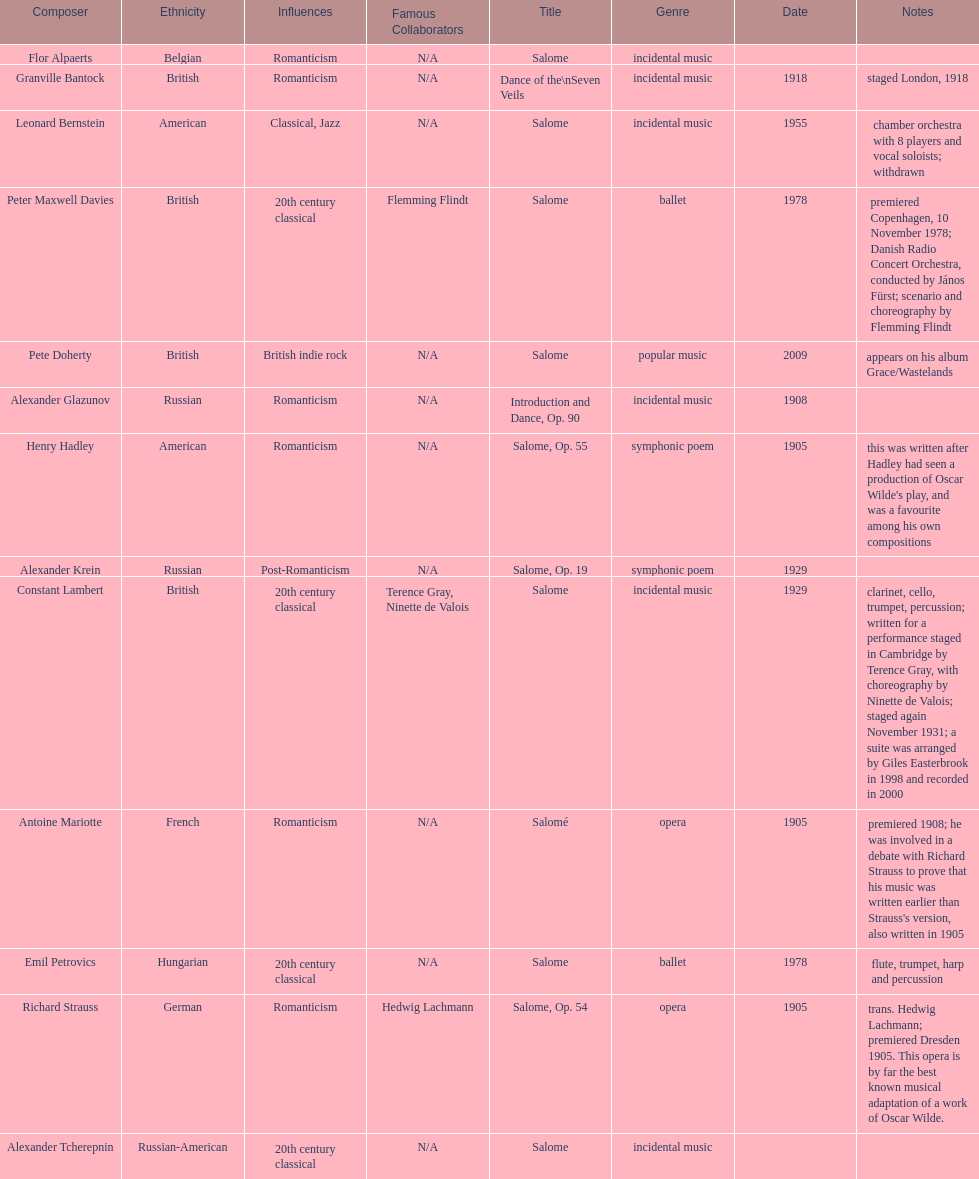What is the number of works titled "salome?" 11. 